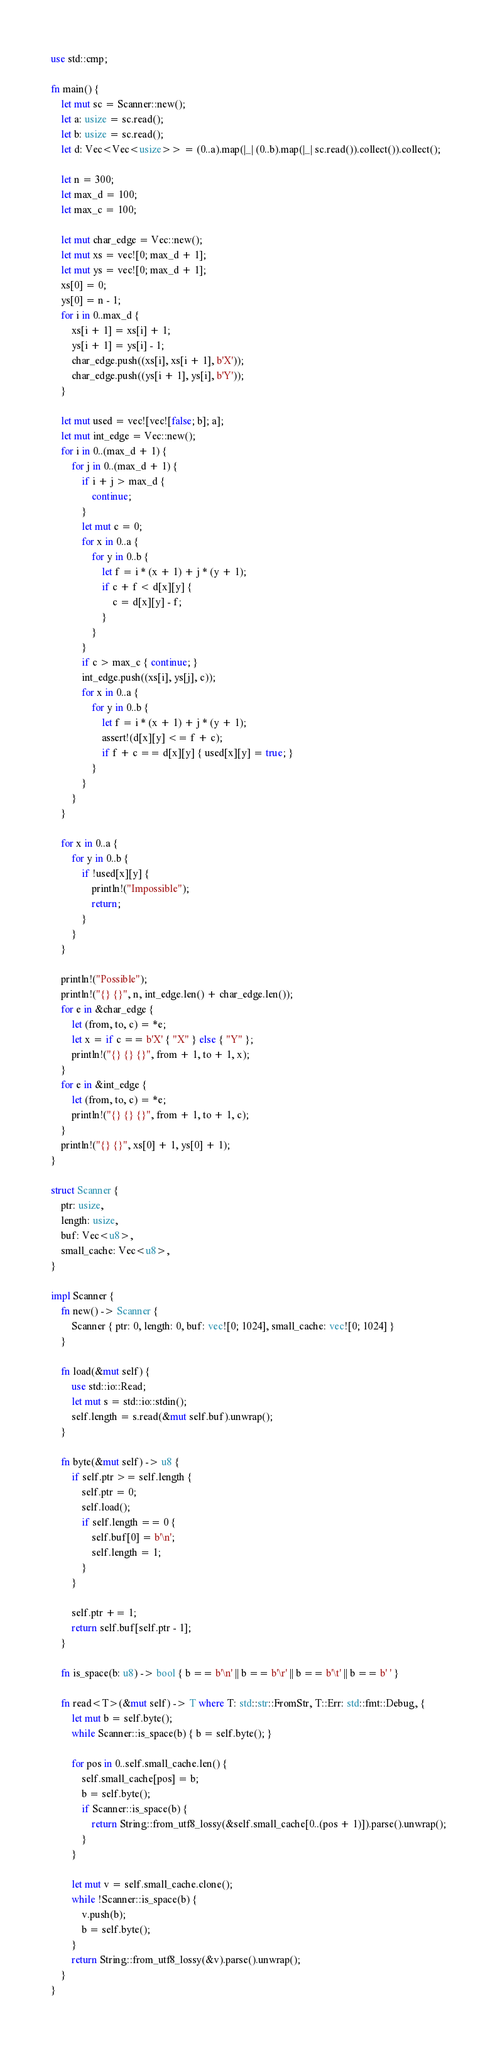Convert code to text. <code><loc_0><loc_0><loc_500><loc_500><_Rust_>use std::cmp;

fn main() {
    let mut sc = Scanner::new();
    let a: usize = sc.read();
    let b: usize = sc.read();
    let d: Vec<Vec<usize>> = (0..a).map(|_| (0..b).map(|_| sc.read()).collect()).collect();

    let n = 300;
    let max_d = 100;
    let max_c = 100;

    let mut char_edge = Vec::new();
    let mut xs = vec![0; max_d + 1];
    let mut ys = vec![0; max_d + 1];
    xs[0] = 0;
    ys[0] = n - 1;
    for i in 0..max_d {
        xs[i + 1] = xs[i] + 1;
        ys[i + 1] = ys[i] - 1;
        char_edge.push((xs[i], xs[i + 1], b'X'));
        char_edge.push((ys[i + 1], ys[i], b'Y'));
    }

    let mut used = vec![vec![false; b]; a];
    let mut int_edge = Vec::new();
    for i in 0..(max_d + 1) {
        for j in 0..(max_d + 1) {
            if i + j > max_d {
                continue;
            }
            let mut c = 0;
            for x in 0..a {
                for y in 0..b {
                    let f = i * (x + 1) + j * (y + 1);
                    if c + f < d[x][y] {
                        c = d[x][y] - f;
                    }
                }
            }
            if c > max_c { continue; }
            int_edge.push((xs[i], ys[j], c));
            for x in 0..a {
                for y in 0..b {
                    let f = i * (x + 1) + j * (y + 1);
                    assert!(d[x][y] <= f + c);
                    if f + c == d[x][y] { used[x][y] = true; }
                }
            }
        }
    }

    for x in 0..a {
        for y in 0..b {
            if !used[x][y] {
                println!("Impossible");
                return;
            }
        }
    }

    println!("Possible");
    println!("{} {}", n, int_edge.len() + char_edge.len());
    for e in &char_edge {
        let (from, to, c) = *e;
        let x = if c == b'X' { "X" } else { "Y" };
        println!("{} {} {}", from + 1, to + 1, x);
    }
    for e in &int_edge {
        let (from, to, c) = *e;
        println!("{} {} {}", from + 1, to + 1, c);
    }
    println!("{} {}", xs[0] + 1, ys[0] + 1);
}

struct Scanner {
    ptr: usize,
    length: usize,
    buf: Vec<u8>,
    small_cache: Vec<u8>,
}

impl Scanner {
    fn new() -> Scanner {
        Scanner { ptr: 0, length: 0, buf: vec![0; 1024], small_cache: vec![0; 1024] }
    }

    fn load(&mut self) {
        use std::io::Read;
        let mut s = std::io::stdin();
        self.length = s.read(&mut self.buf).unwrap();
    }

    fn byte(&mut self) -> u8 {
        if self.ptr >= self.length {
            self.ptr = 0;
            self.load();
            if self.length == 0 {
                self.buf[0] = b'\n';
                self.length = 1;
            }
        }

        self.ptr += 1;
        return self.buf[self.ptr - 1];
    }

    fn is_space(b: u8) -> bool { b == b'\n' || b == b'\r' || b == b'\t' || b == b' ' }

    fn read<T>(&mut self) -> T where T: std::str::FromStr, T::Err: std::fmt::Debug, {
        let mut b = self.byte();
        while Scanner::is_space(b) { b = self.byte(); }

        for pos in 0..self.small_cache.len() {
            self.small_cache[pos] = b;
            b = self.byte();
            if Scanner::is_space(b) {
                return String::from_utf8_lossy(&self.small_cache[0..(pos + 1)]).parse().unwrap();
            }
        }

        let mut v = self.small_cache.clone();
        while !Scanner::is_space(b) {
            v.push(b);
            b = self.byte();
        }
        return String::from_utf8_lossy(&v).parse().unwrap();
    }
}

</code> 